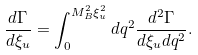<formula> <loc_0><loc_0><loc_500><loc_500>\frac { d \Gamma } { d \xi _ { u } } = \int _ { 0 } ^ { M _ { B } ^ { 2 } \xi _ { u } ^ { 2 } } d q ^ { 2 } \frac { d ^ { 2 } \Gamma } { d \xi _ { u } d q ^ { 2 } } .</formula> 